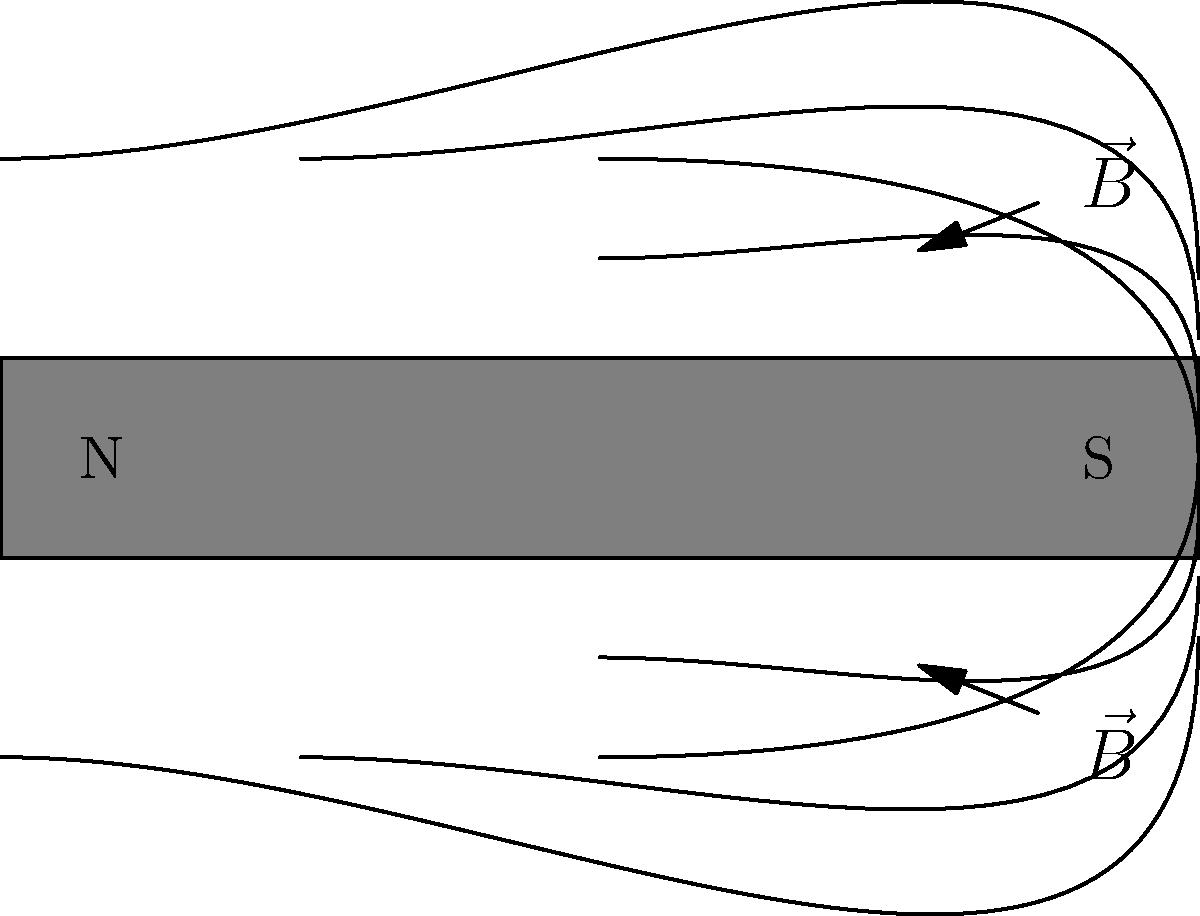In the diagram above, magnetic field lines are shown around a bar magnet. How would you describe the density of these lines near the poles compared to the middle of the magnet, and what does this indicate about the strength of the magnetic field in these regions? To answer this question, let's analyse the diagram step-by-step:

1. Observe the magnetic field lines:
   The lines emerge from the North (N) pole and enter the South (S) pole of the magnet.

2. Examine the density of field lines:
   Near the poles, the field lines are more closely packed together.
   In the middle region of the magnet, the field lines are more spread out.

3. Understand the relationship between field line density and field strength:
   The density of magnetic field lines is directly proportional to the strength of the magnetic field.

4. Compare the regions:
   The higher density of field lines near the poles indicates a stronger magnetic field in these areas.
   The lower density of field lines in the middle region indicates a weaker magnetic field.

5. Consider the physical interpretation:
   The poles are the focal points of the magnet's strength, where the magnetic effect is most concentrated.

Therefore, the density of magnetic field lines is greater near the poles and lesser in the middle of the magnet, indicating that the magnetic field is stronger near the poles and weaker in the middle region.
Answer: Higher density near poles; lower in middle. Indicates stronger field at poles, weaker in middle. 